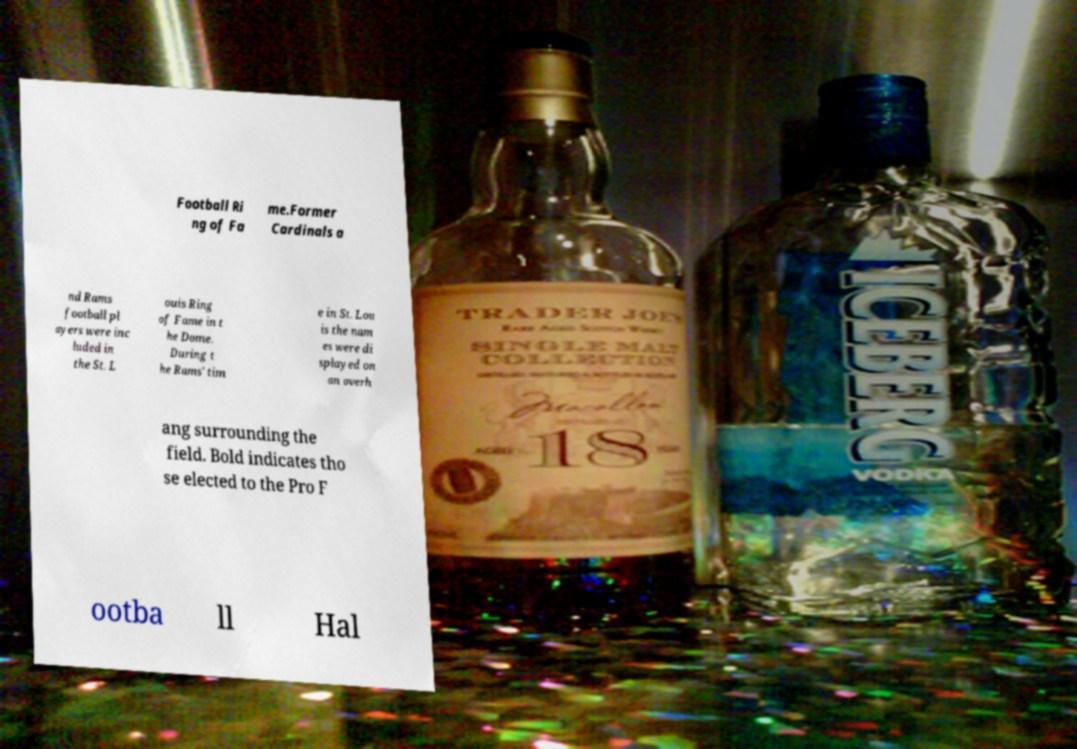Can you read and provide the text displayed in the image?This photo seems to have some interesting text. Can you extract and type it out for me? Football Ri ng of Fa me.Former Cardinals a nd Rams football pl ayers were inc luded in the St. L ouis Ring of Fame in t he Dome. During t he Rams' tim e in St. Lou is the nam es were di splayed on an overh ang surrounding the field. Bold indicates tho se elected to the Pro F ootba ll Hal 